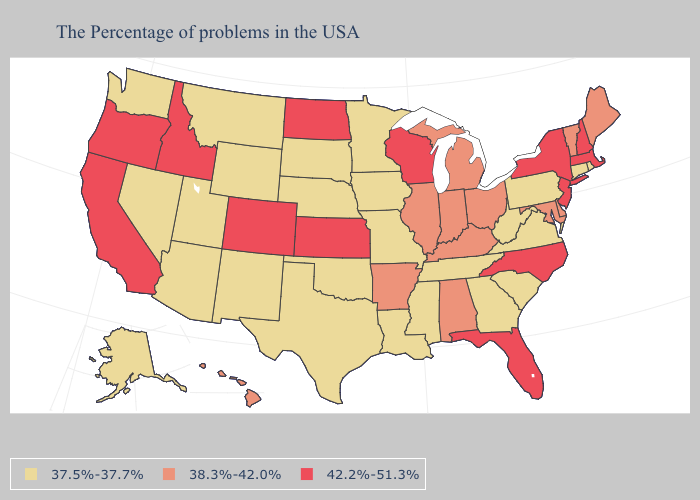Does the first symbol in the legend represent the smallest category?
Give a very brief answer. Yes. Does Iowa have the same value as Arizona?
Quick response, please. Yes. Name the states that have a value in the range 37.5%-37.7%?
Answer briefly. Rhode Island, Connecticut, Pennsylvania, Virginia, South Carolina, West Virginia, Georgia, Tennessee, Mississippi, Louisiana, Missouri, Minnesota, Iowa, Nebraska, Oklahoma, Texas, South Dakota, Wyoming, New Mexico, Utah, Montana, Arizona, Nevada, Washington, Alaska. What is the value of Kansas?
Write a very short answer. 42.2%-51.3%. Does Illinois have the same value as Alaska?
Write a very short answer. No. What is the highest value in the USA?
Concise answer only. 42.2%-51.3%. Which states hav the highest value in the South?
Be succinct. North Carolina, Florida. Among the states that border Texas , does Arkansas have the highest value?
Keep it brief. Yes. Name the states that have a value in the range 42.2%-51.3%?
Answer briefly. Massachusetts, New Hampshire, New York, New Jersey, North Carolina, Florida, Wisconsin, Kansas, North Dakota, Colorado, Idaho, California, Oregon. Among the states that border Ohio , does Michigan have the lowest value?
Concise answer only. No. Name the states that have a value in the range 42.2%-51.3%?
Answer briefly. Massachusetts, New Hampshire, New York, New Jersey, North Carolina, Florida, Wisconsin, Kansas, North Dakota, Colorado, Idaho, California, Oregon. What is the lowest value in the Northeast?
Be succinct. 37.5%-37.7%. Name the states that have a value in the range 42.2%-51.3%?
Keep it brief. Massachusetts, New Hampshire, New York, New Jersey, North Carolina, Florida, Wisconsin, Kansas, North Dakota, Colorado, Idaho, California, Oregon. Name the states that have a value in the range 38.3%-42.0%?
Short answer required. Maine, Vermont, Delaware, Maryland, Ohio, Michigan, Kentucky, Indiana, Alabama, Illinois, Arkansas, Hawaii. Among the states that border New Jersey , does Delaware have the highest value?
Concise answer only. No. 